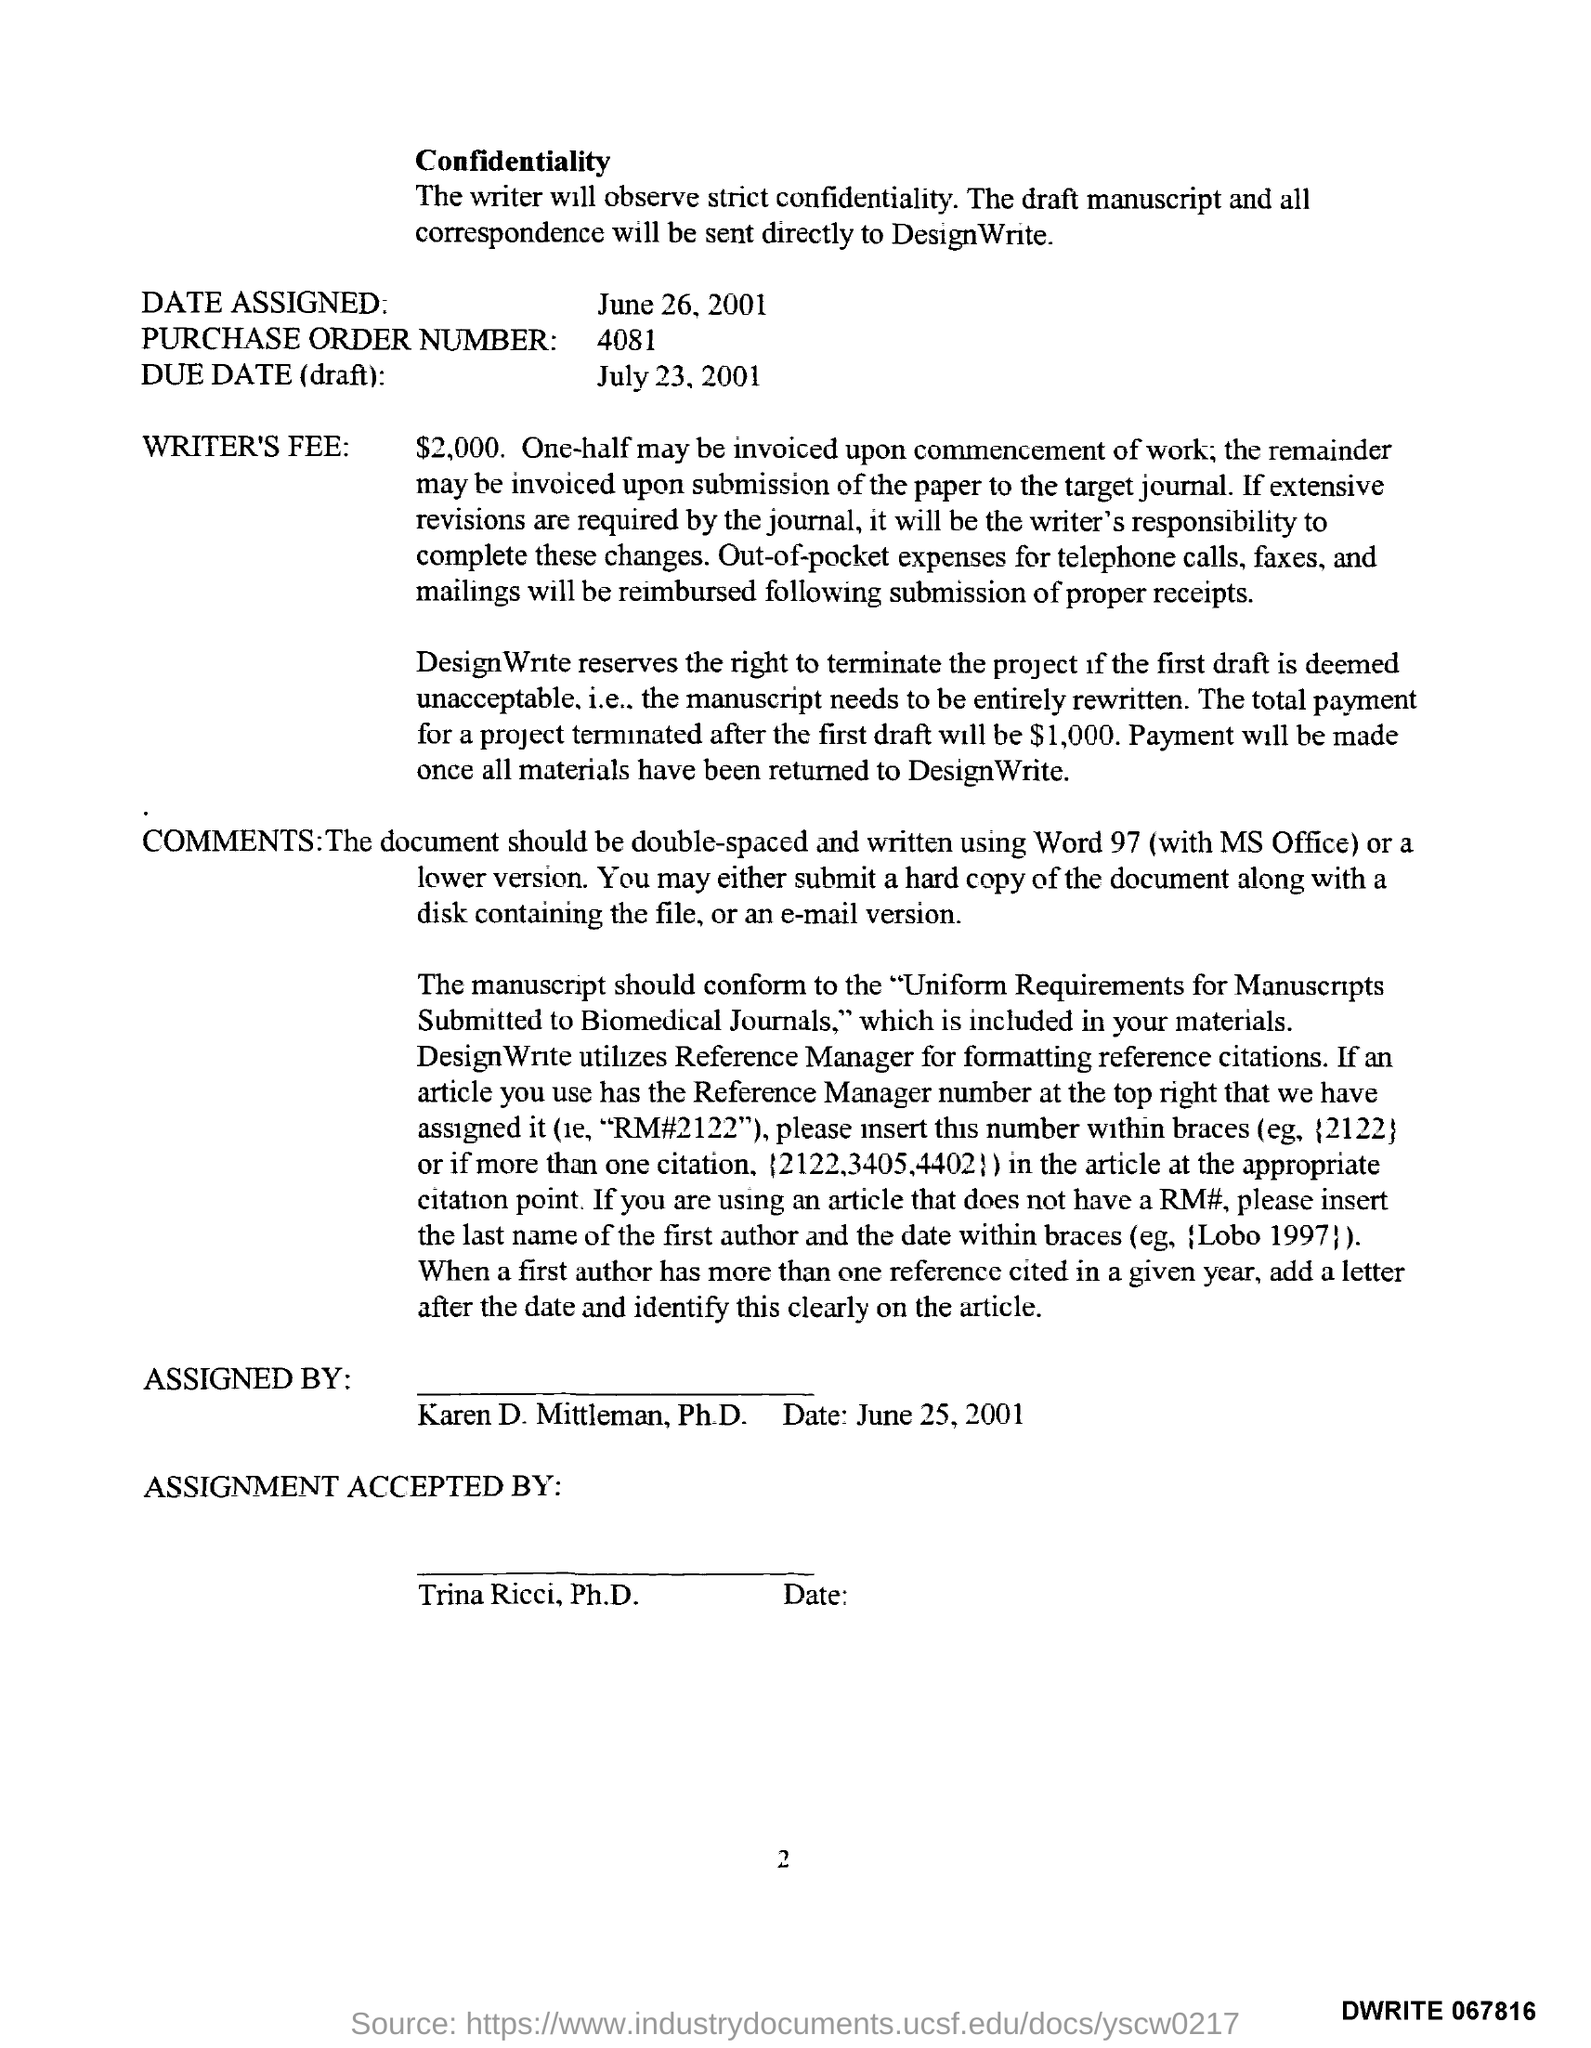Draw attention to some important aspects in this diagram. The page number is 2. The due date is July 23, 2001. The purchase order number is 4081. Trina Ricci, Ph.D., has accepted the assignment. What is 'date assigned'? It is June 26, 2001. 